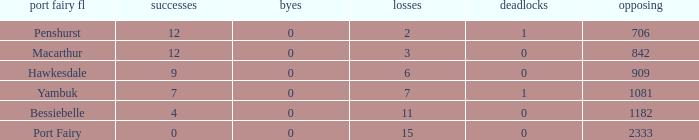How many byes when the draws are less than 0? 0.0. 